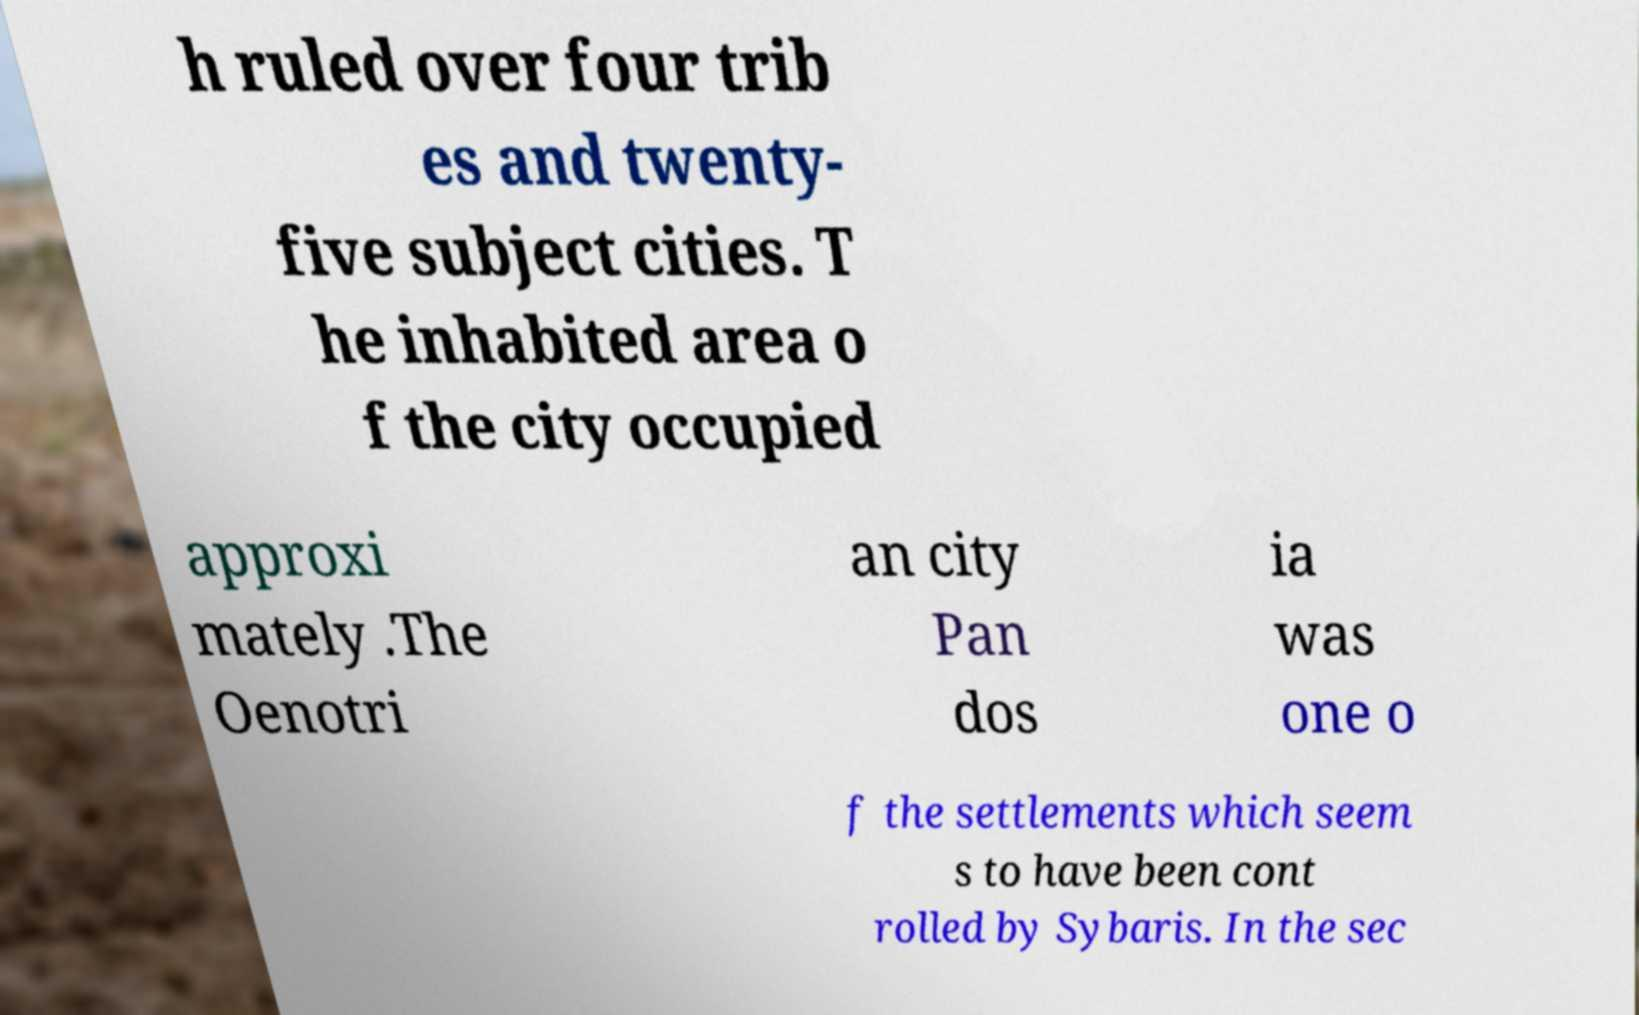Can you accurately transcribe the text from the provided image for me? h ruled over four trib es and twenty- five subject cities. T he inhabited area o f the city occupied approxi mately .The Oenotri an city Pan dos ia was one o f the settlements which seem s to have been cont rolled by Sybaris. In the sec 